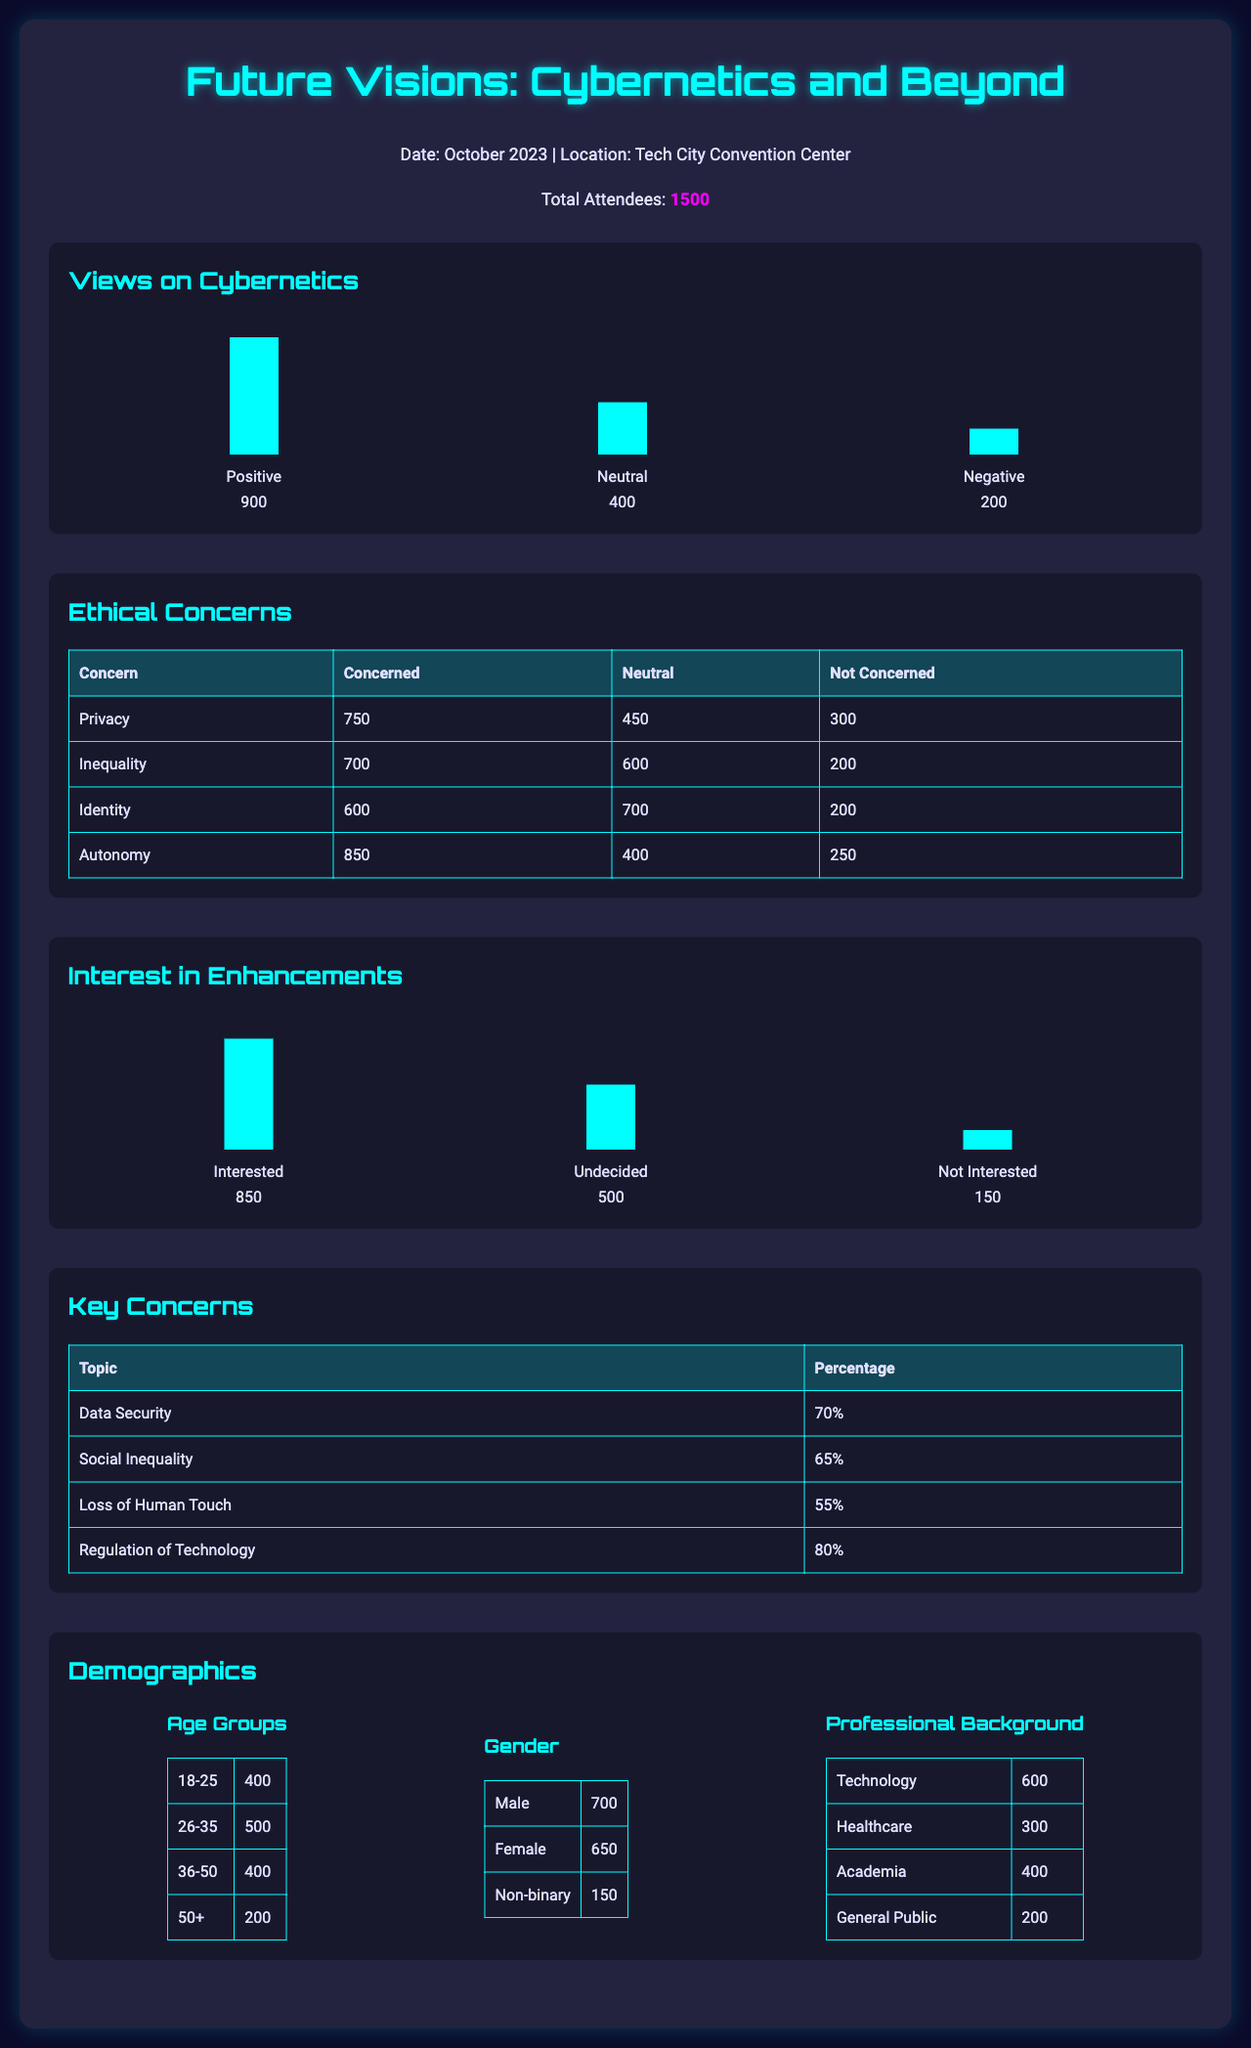What percentage of attendees have positive views on cybernetics? The percentage can be calculated from the number of attendees with positive views, which is 900 out of 1500 total attendees, leading to 60%.
Answer: 60% How many attendees expressed concern about privacy? The document indicates that 750 attendees are concerned about privacy.
Answer: 750 What is the main ethical concern regarding regulation of technology? The percentage of attendees concerned about regulation of technology is identified as 80%.
Answer: 80% What is the total number of attendees who are interested in cybernetic enhancements? According to the data, 850 attendees expressed interest in cybernetic enhancements.
Answer: 850 How many attendees are not interested in cybernetic enhancements? The document states that 150 attendees are not interested in cybernetic enhancements.
Answer: 150 Which demographic has the highest representation among attendees? The age group 26-35 has the highest number of attendees at 500.
Answer: 26-35 What is the combined total of attendees concerned about identity and autonomy? The number of attendees concerned about identity (600) plus those concerned about autonomy (850) equals 1450.
Answer: 1450 What is the total number of males and females combined? The total number is calculated by adding 700 males and 650 females, resulting in 1350.
Answer: 1350 